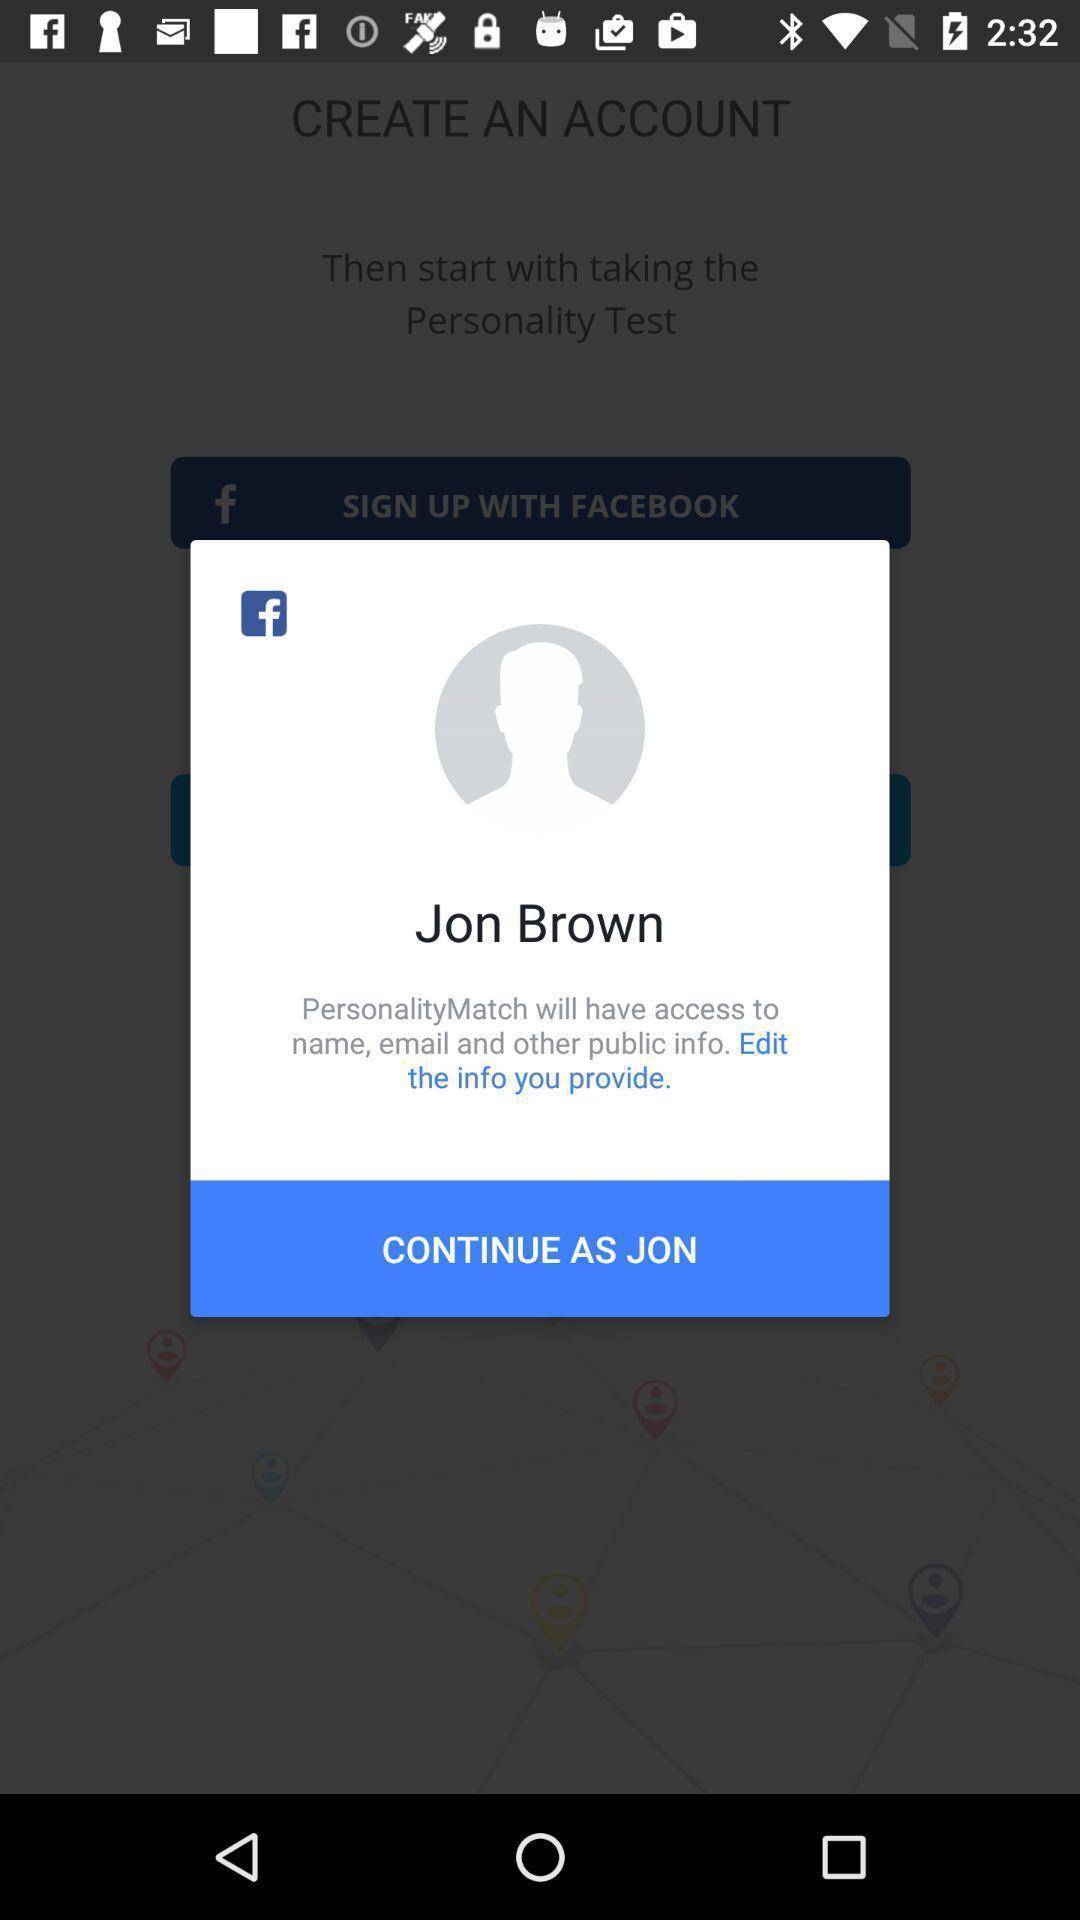Please provide a description for this image. Profile page of a person in a social app. 